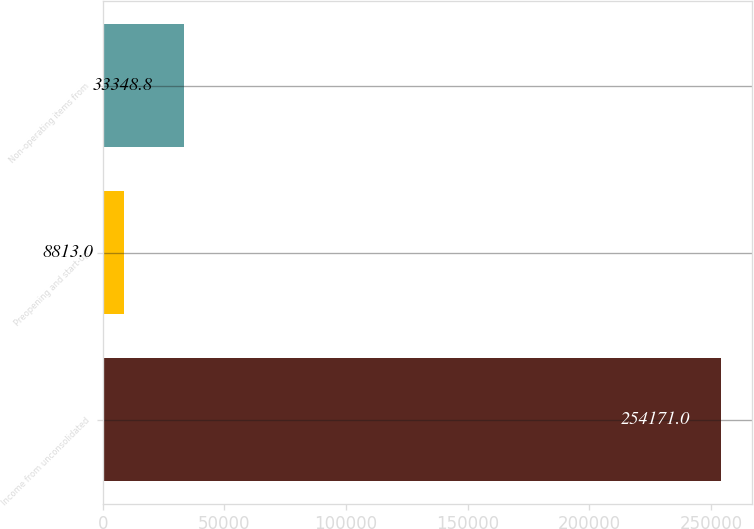Convert chart. <chart><loc_0><loc_0><loc_500><loc_500><bar_chart><fcel>Income from unconsolidated<fcel>Preopening and start-up<fcel>Non-operating items from<nl><fcel>254171<fcel>8813<fcel>33348.8<nl></chart> 